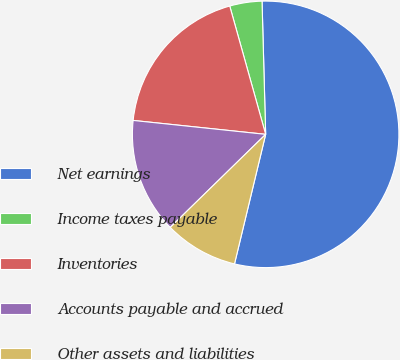Convert chart to OTSL. <chart><loc_0><loc_0><loc_500><loc_500><pie_chart><fcel>Net earnings<fcel>Income taxes payable<fcel>Inventories<fcel>Accounts payable and accrued<fcel>Other assets and liabilities<nl><fcel>54.19%<fcel>3.91%<fcel>18.99%<fcel>13.97%<fcel>8.94%<nl></chart> 